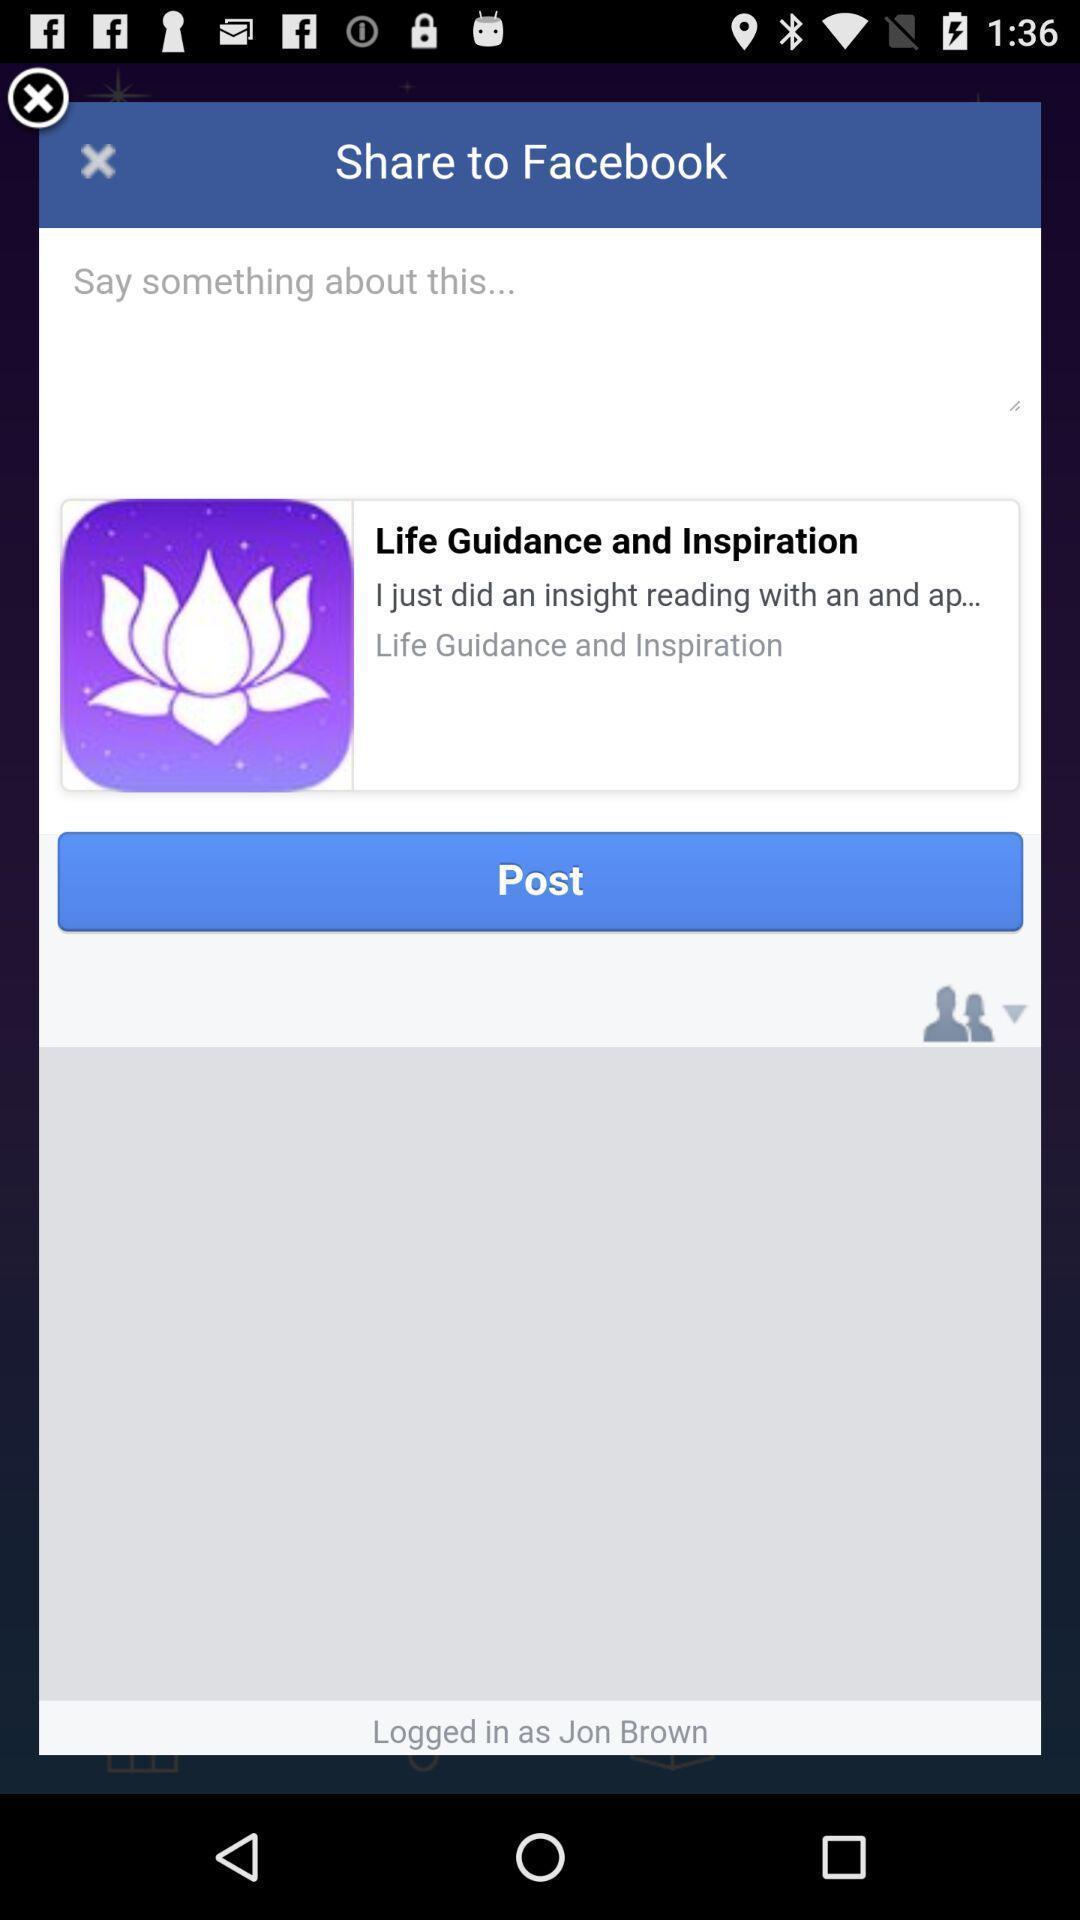Tell me what you see in this picture. Pop up displaying sharing of post in social app. 